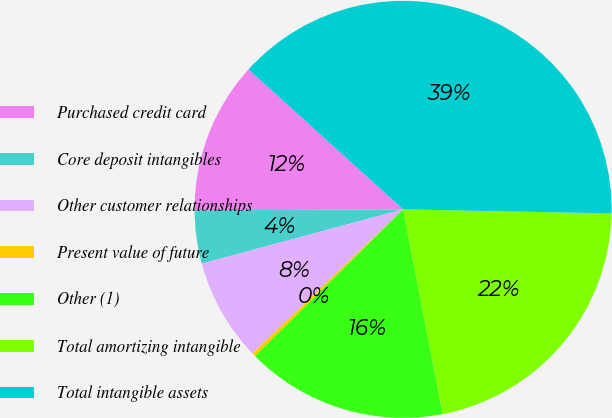Convert chart to OTSL. <chart><loc_0><loc_0><loc_500><loc_500><pie_chart><fcel>Purchased credit card<fcel>Core deposit intangibles<fcel>Other customer relationships<fcel>Present value of future<fcel>Other (1)<fcel>Total amortizing intangible<fcel>Total intangible assets<nl><fcel>11.78%<fcel>4.12%<fcel>7.95%<fcel>0.29%<fcel>15.61%<fcel>21.64%<fcel>38.6%<nl></chart> 